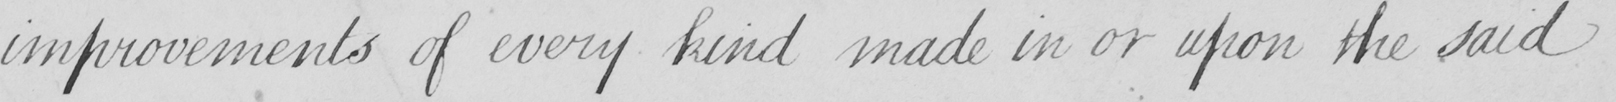Can you read and transcribe this handwriting? improvements of every kind made in or upon the said 